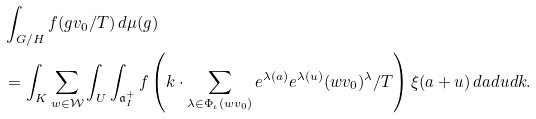Convert formula to latex. <formula><loc_0><loc_0><loc_500><loc_500>& \int _ { G / H } f ( g v _ { 0 } / T ) \, d \mu ( g ) \\ & = \int _ { K } \sum _ { w \in \mathcal { W } } \int _ { U } \int _ { \mathfrak { a } _ { I } ^ { + } } f \left ( k \cdot \sum _ { \lambda \in \Phi _ { \iota } ( w v _ { 0 } ) } e ^ { \lambda ( a ) } e ^ { \lambda ( u ) } ( w v _ { 0 } ) ^ { \lambda } / T \right ) \xi ( a + u ) \, d a d u d k .</formula> 